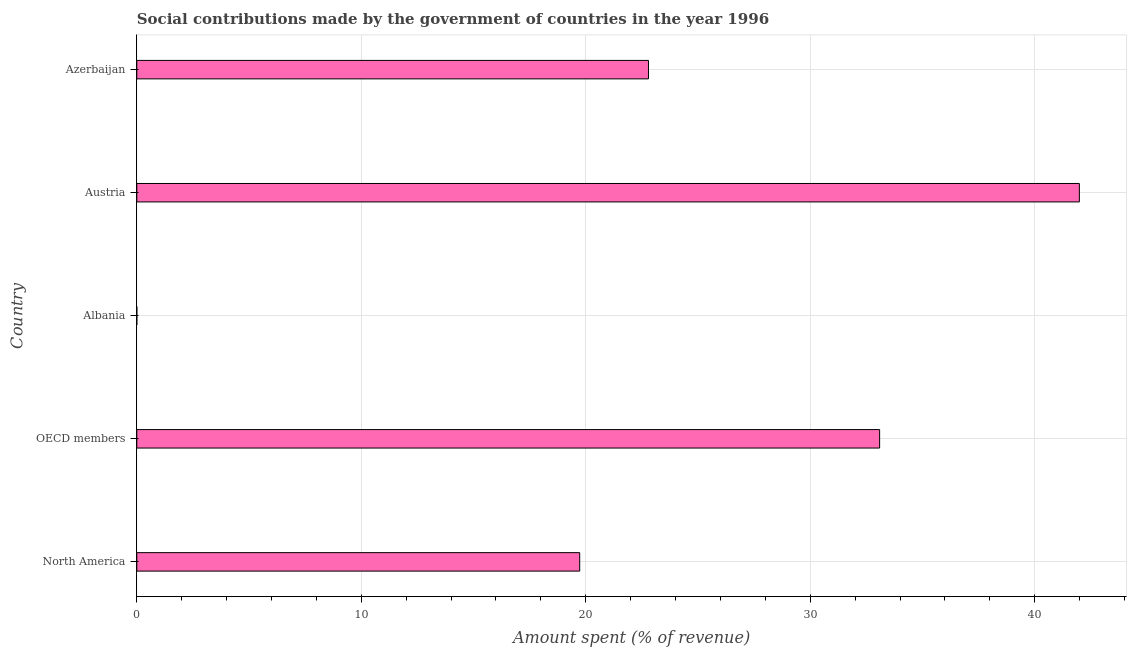Does the graph contain any zero values?
Your response must be concise. No. Does the graph contain grids?
Keep it short and to the point. Yes. What is the title of the graph?
Offer a terse response. Social contributions made by the government of countries in the year 1996. What is the label or title of the X-axis?
Provide a succinct answer. Amount spent (% of revenue). What is the label or title of the Y-axis?
Give a very brief answer. Country. What is the amount spent in making social contributions in OECD members?
Ensure brevity in your answer.  33.09. Across all countries, what is the maximum amount spent in making social contributions?
Offer a terse response. 41.99. Across all countries, what is the minimum amount spent in making social contributions?
Provide a succinct answer. 5.27984526251892e-6. In which country was the amount spent in making social contributions maximum?
Provide a short and direct response. Austria. In which country was the amount spent in making social contributions minimum?
Make the answer very short. Albania. What is the sum of the amount spent in making social contributions?
Provide a short and direct response. 117.6. What is the difference between the amount spent in making social contributions in Austria and OECD members?
Your answer should be very brief. 8.9. What is the average amount spent in making social contributions per country?
Offer a terse response. 23.52. What is the median amount spent in making social contributions?
Keep it short and to the point. 22.79. In how many countries, is the amount spent in making social contributions greater than 14 %?
Make the answer very short. 4. What is the ratio of the amount spent in making social contributions in Azerbaijan to that in North America?
Your answer should be very brief. 1.16. Is the difference between the amount spent in making social contributions in Azerbaijan and North America greater than the difference between any two countries?
Offer a terse response. No. What is the difference between the highest and the second highest amount spent in making social contributions?
Give a very brief answer. 8.9. Is the sum of the amount spent in making social contributions in Albania and Austria greater than the maximum amount spent in making social contributions across all countries?
Provide a succinct answer. Yes. What is the difference between the highest and the lowest amount spent in making social contributions?
Offer a very short reply. 41.99. In how many countries, is the amount spent in making social contributions greater than the average amount spent in making social contributions taken over all countries?
Ensure brevity in your answer.  2. How many bars are there?
Offer a terse response. 5. Are all the bars in the graph horizontal?
Ensure brevity in your answer.  Yes. What is the difference between two consecutive major ticks on the X-axis?
Give a very brief answer. 10. What is the Amount spent (% of revenue) in North America?
Your answer should be very brief. 19.73. What is the Amount spent (% of revenue) of OECD members?
Ensure brevity in your answer.  33.09. What is the Amount spent (% of revenue) of Albania?
Your response must be concise. 5.27984526251892e-6. What is the Amount spent (% of revenue) in Austria?
Your answer should be very brief. 41.99. What is the Amount spent (% of revenue) in Azerbaijan?
Provide a succinct answer. 22.79. What is the difference between the Amount spent (% of revenue) in North America and OECD members?
Your answer should be compact. -13.36. What is the difference between the Amount spent (% of revenue) in North America and Albania?
Offer a very short reply. 19.73. What is the difference between the Amount spent (% of revenue) in North America and Austria?
Your answer should be compact. -22.26. What is the difference between the Amount spent (% of revenue) in North America and Azerbaijan?
Your response must be concise. -3.06. What is the difference between the Amount spent (% of revenue) in OECD members and Albania?
Keep it short and to the point. 33.09. What is the difference between the Amount spent (% of revenue) in OECD members and Austria?
Make the answer very short. -8.9. What is the difference between the Amount spent (% of revenue) in OECD members and Azerbaijan?
Offer a very short reply. 10.3. What is the difference between the Amount spent (% of revenue) in Albania and Austria?
Your response must be concise. -41.99. What is the difference between the Amount spent (% of revenue) in Albania and Azerbaijan?
Your response must be concise. -22.79. What is the difference between the Amount spent (% of revenue) in Austria and Azerbaijan?
Offer a very short reply. 19.19. What is the ratio of the Amount spent (% of revenue) in North America to that in OECD members?
Your answer should be compact. 0.6. What is the ratio of the Amount spent (% of revenue) in North America to that in Albania?
Your response must be concise. 3.74e+06. What is the ratio of the Amount spent (% of revenue) in North America to that in Austria?
Your answer should be very brief. 0.47. What is the ratio of the Amount spent (% of revenue) in North America to that in Azerbaijan?
Your answer should be compact. 0.87. What is the ratio of the Amount spent (% of revenue) in OECD members to that in Albania?
Ensure brevity in your answer.  6.27e+06. What is the ratio of the Amount spent (% of revenue) in OECD members to that in Austria?
Give a very brief answer. 0.79. What is the ratio of the Amount spent (% of revenue) in OECD members to that in Azerbaijan?
Provide a succinct answer. 1.45. What is the ratio of the Amount spent (% of revenue) in Albania to that in Azerbaijan?
Keep it short and to the point. 0. What is the ratio of the Amount spent (% of revenue) in Austria to that in Azerbaijan?
Provide a short and direct response. 1.84. 